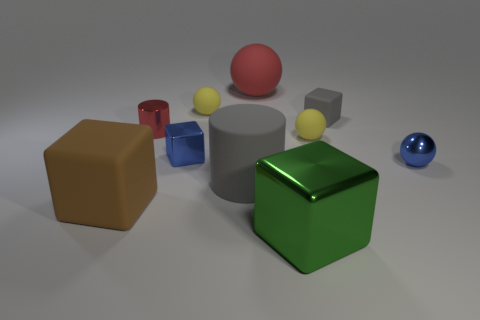Is the tiny yellow sphere on the left side of the rubber cylinder made of the same material as the tiny yellow object on the right side of the big gray thing?
Your answer should be very brief. Yes. Is the number of big things that are behind the blue ball less than the number of tiny rubber cubes?
Your response must be concise. No. There is a large matte object that is behind the tiny metal cylinder; how many big gray objects are behind it?
Offer a very short reply. 0. What is the size of the cube that is right of the rubber cylinder and in front of the shiny cylinder?
Keep it short and to the point. Large. Is there anything else that has the same material as the big brown cube?
Make the answer very short. Yes. Does the gray cylinder have the same material as the blue object behind the metal ball?
Provide a short and direct response. No. Is the number of red matte spheres that are in front of the big brown object less than the number of small yellow rubber spheres that are in front of the red cylinder?
Your answer should be compact. Yes. What material is the large cube that is to the left of the big green shiny cube?
Give a very brief answer. Rubber. There is a thing that is in front of the big gray rubber thing and left of the big red thing; what is its color?
Provide a succinct answer. Brown. How many other objects are there of the same color as the big cylinder?
Make the answer very short. 1. 